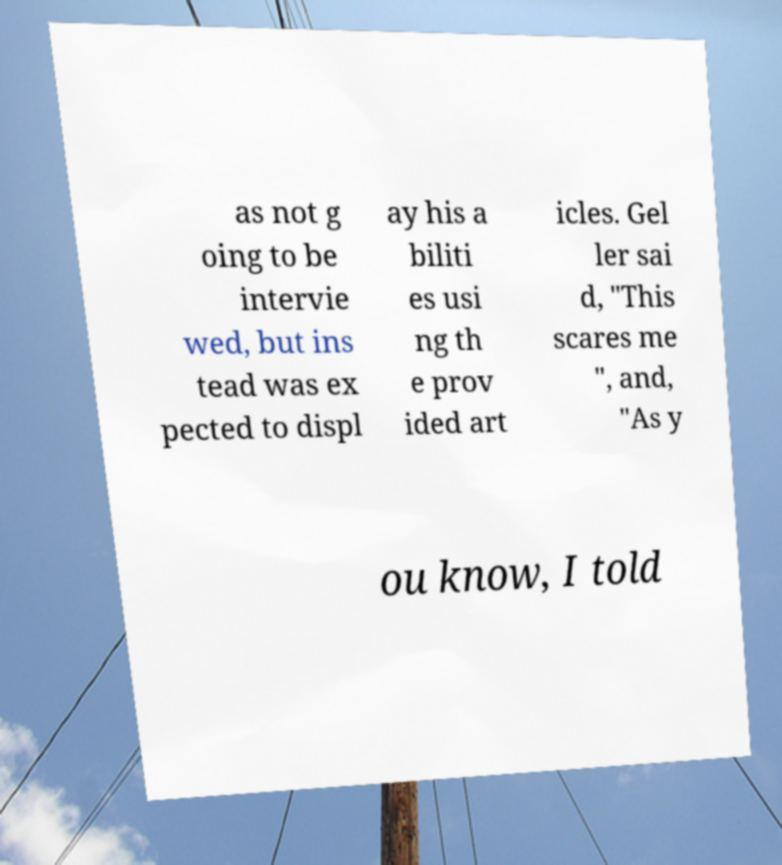For documentation purposes, I need the text within this image transcribed. Could you provide that? as not g oing to be intervie wed, but ins tead was ex pected to displ ay his a biliti es usi ng th e prov ided art icles. Gel ler sai d, "This scares me ", and, "As y ou know, I told 